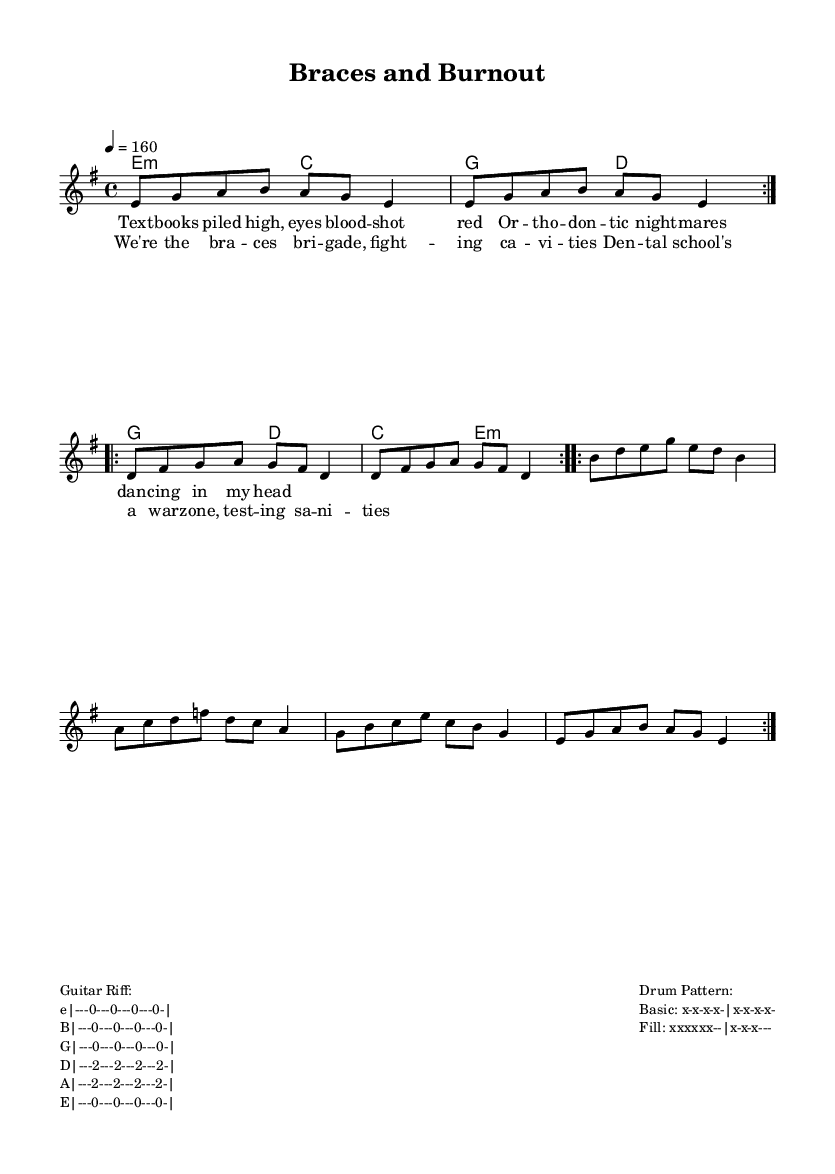What is the key signature of this music? The key signature is E minor, which has one sharp (F#). This is indicated in the global settings of the sheet music.
Answer: E minor What is the time signature of this music? The time signature is 4/4, which means there are four beats in each measure. This is also defined in the global settings section of the sheet music.
Answer: 4/4 What is the tempo marking for this piece? The tempo marking is 160 beats per minute, as specified in the global section. This indicates how fast the piece should be played.
Answer: 160 How many times is the melody repeated? The melody is repeated twice, as indicated by the \repeat volta 2 command in the melody section of the code.
Answer: 2 What is the main theme of the lyrics? The main theme of the lyrics revolves around the challenges of dental school, depicted with phrases like "books piled high" and "fighting cavities." This reflects the stressful experiences of students.
Answer: Dental school challenges Is there a specific guitar riff provided? Yes, there is a guitar riff provided which outlines specific notes to play along with the chords. This riff typically captures the punk aesthetic with its simple yet catchy progression.
Answer: Yes 